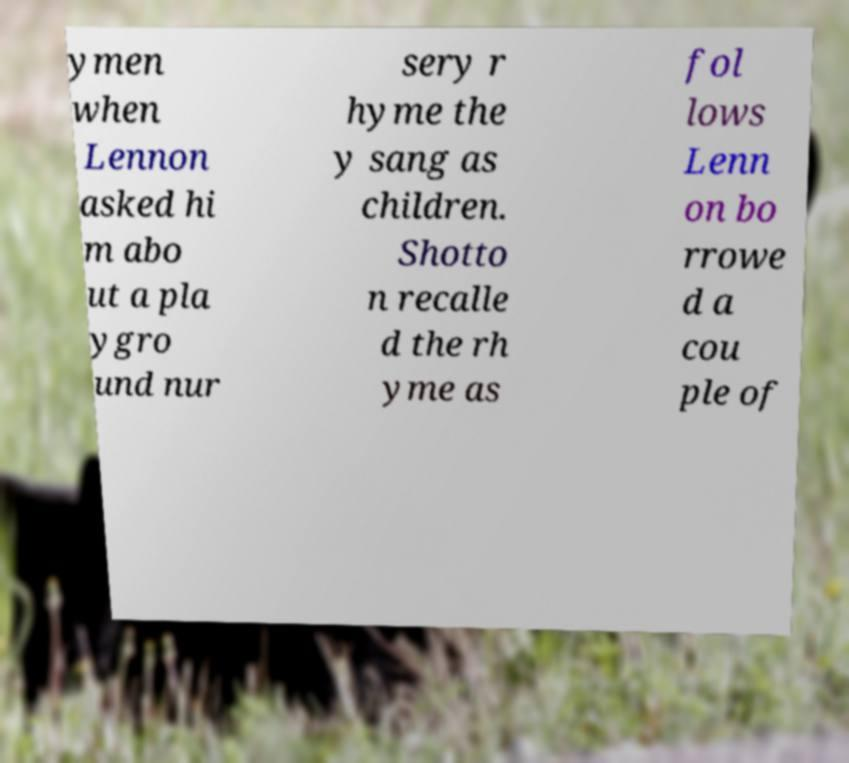Please read and relay the text visible in this image. What does it say? ymen when Lennon asked hi m abo ut a pla ygro und nur sery r hyme the y sang as children. Shotto n recalle d the rh yme as fol lows Lenn on bo rrowe d a cou ple of 